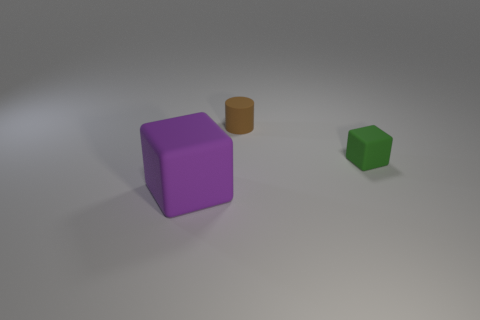Is the small green object made of the same material as the tiny object that is behind the green object? While I am not able to physically examine the objects, based on the visual cues presented in the image, it appears that both the small green object and the tiny brown object behind it have a matte finish and are likely made from a similar plastic material. Their shadows indicate a similar kind of solidity suggesting they share material properties. 